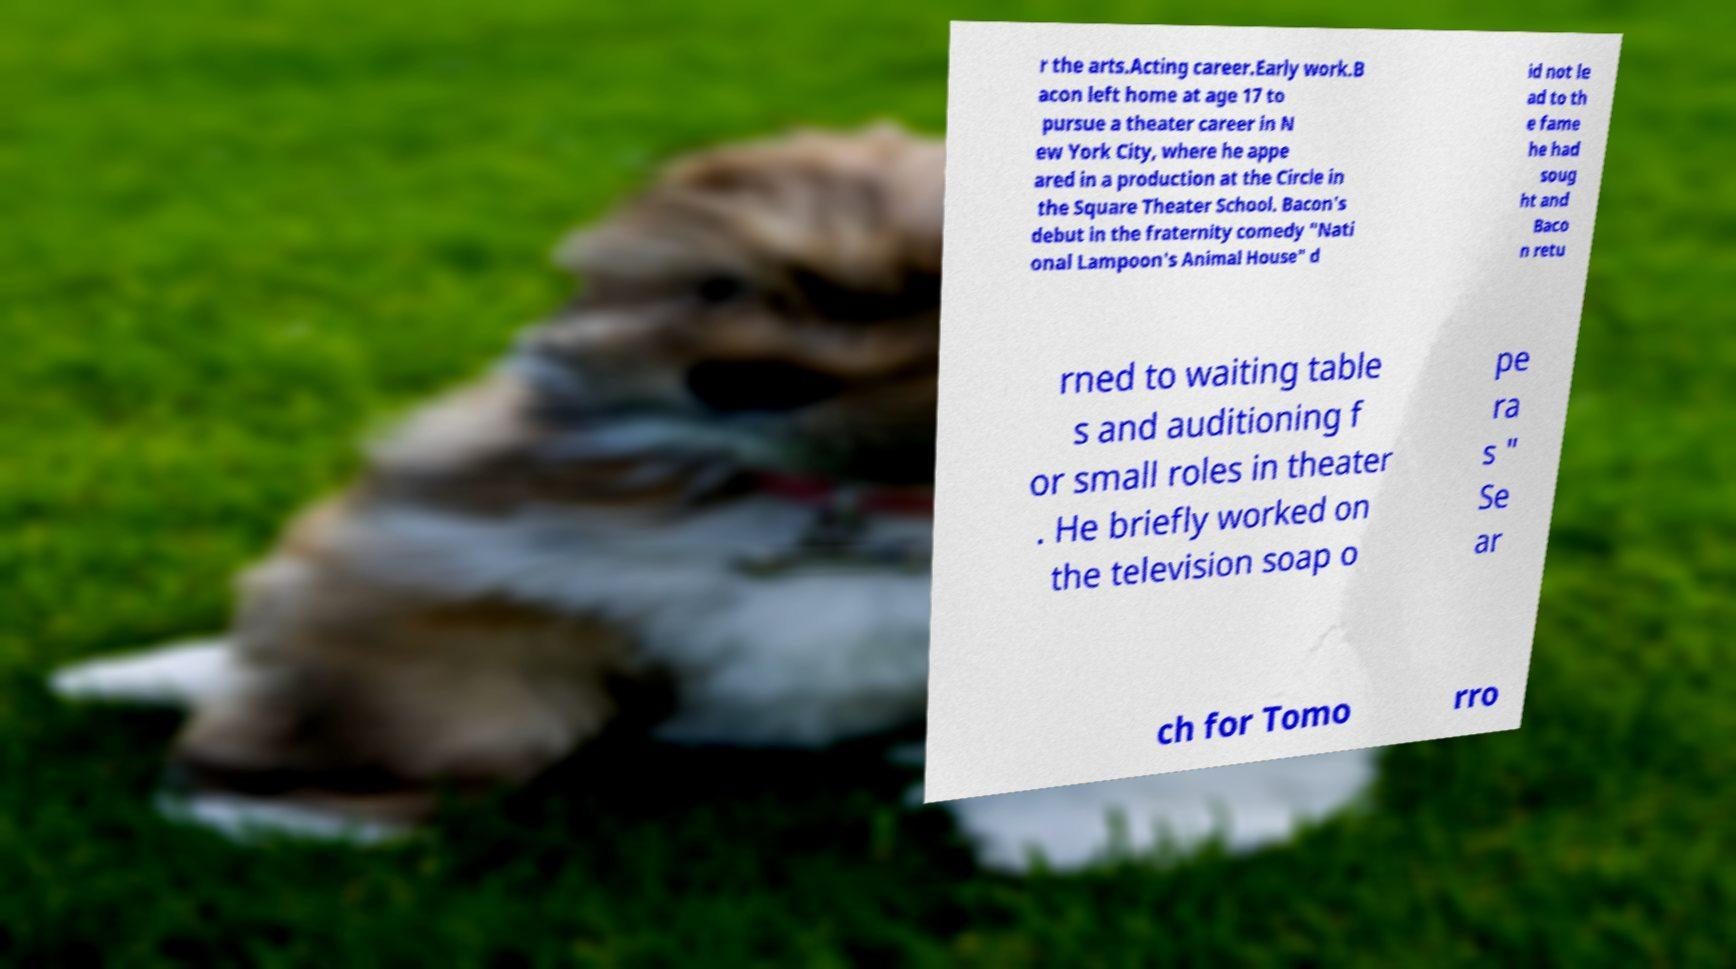Could you extract and type out the text from this image? r the arts.Acting career.Early work.B acon left home at age 17 to pursue a theater career in N ew York City, where he appe ared in a production at the Circle in the Square Theater School. Bacon's debut in the fraternity comedy "Nati onal Lampoon's Animal House" d id not le ad to th e fame he had soug ht and Baco n retu rned to waiting table s and auditioning f or small roles in theater . He briefly worked on the television soap o pe ra s " Se ar ch for Tomo rro 